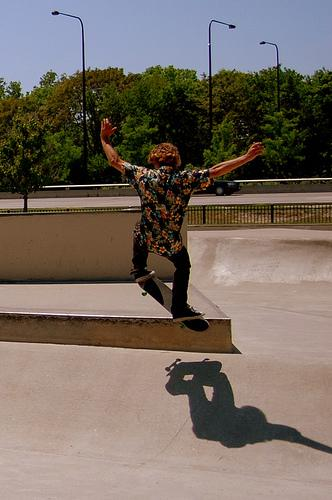Question: where is this photo taken?
Choices:
A. A skatepark.
B. At the beach.
C. In the yard.
D. In the street.
Answer with the letter. Answer: A Question: why is the skater jumping?
Choices:
A. The skater is performing a trick.
B. For the show.
C. Practicing.
D. To leap over the wall.
Answer with the letter. Answer: A Question: what is the skater doing?
Choices:
A. Slipping.
B. Circling.
C. Taking off his shoes.
D. Skateboarding.
Answer with the letter. Answer: D Question: who is on the skateboard?
Choices:
A. The child.
B. The dog.
C. A skateboarder.
D. The professional.
Answer with the letter. Answer: C 